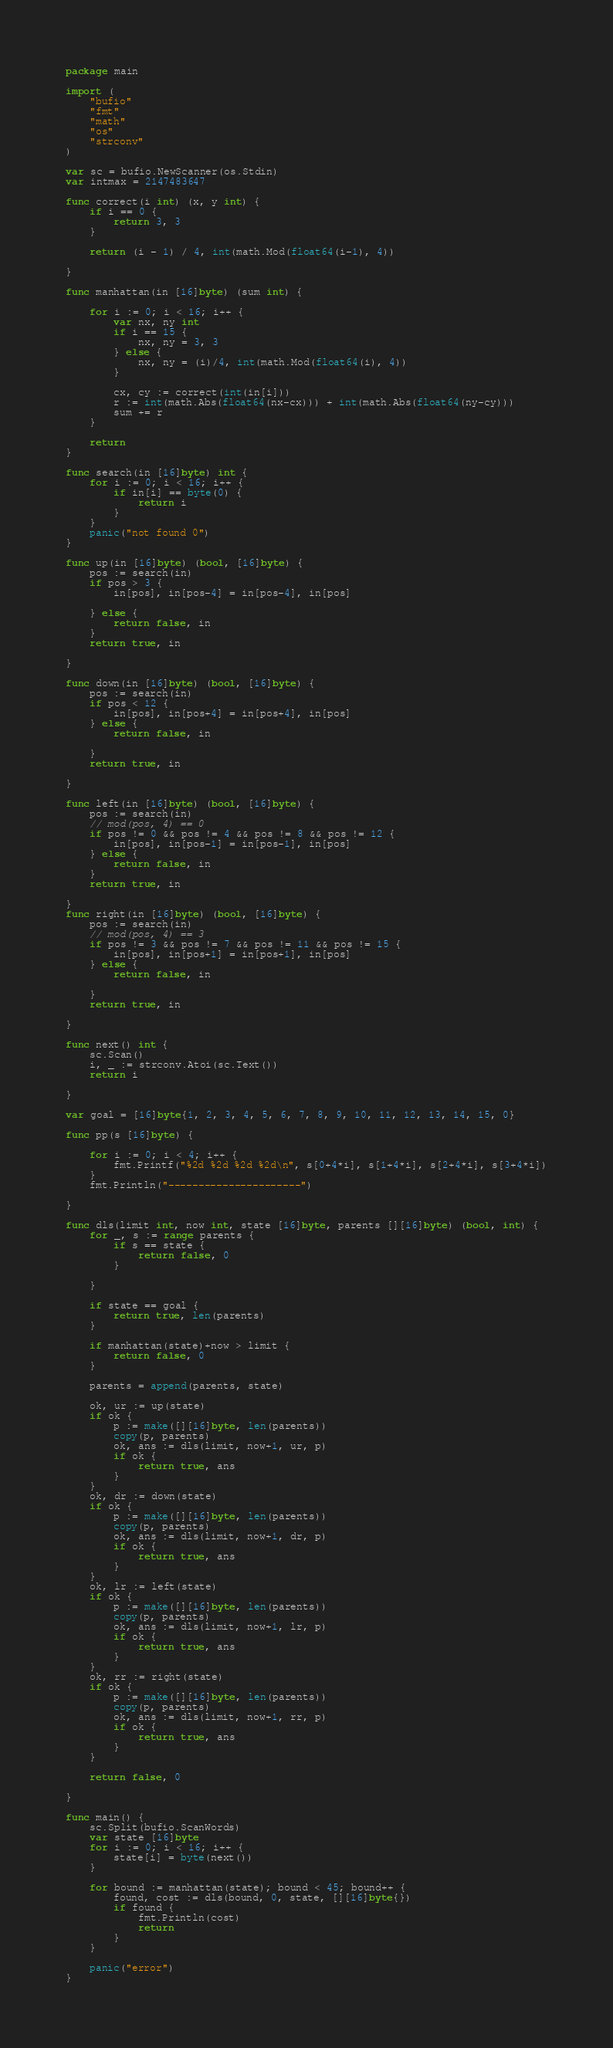<code> <loc_0><loc_0><loc_500><loc_500><_Go_>package main

import (
	"bufio"
	"fmt"
	"math"
	"os"
	"strconv"
)

var sc = bufio.NewScanner(os.Stdin)
var intmax = 2147483647

func correct(i int) (x, y int) {
	if i == 0 {
		return 3, 3
	}

	return (i - 1) / 4, int(math.Mod(float64(i-1), 4))

}

func manhattan(in [16]byte) (sum int) {

	for i := 0; i < 16; i++ {
		var nx, ny int
		if i == 15 {
			nx, ny = 3, 3
		} else {
			nx, ny = (i)/4, int(math.Mod(float64(i), 4))
		}

		cx, cy := correct(int(in[i]))
		r := int(math.Abs(float64(nx-cx))) + int(math.Abs(float64(ny-cy)))
		sum += r
	}

	return
}

func search(in [16]byte) int {
	for i := 0; i < 16; i++ {
		if in[i] == byte(0) {
			return i
		}
	}
	panic("not found 0")
}

func up(in [16]byte) (bool, [16]byte) {
	pos := search(in)
	if pos > 3 {
		in[pos], in[pos-4] = in[pos-4], in[pos]

	} else {
		return false, in
	}
	return true, in

}

func down(in [16]byte) (bool, [16]byte) {
	pos := search(in)
	if pos < 12 {
		in[pos], in[pos+4] = in[pos+4], in[pos]
	} else {
		return false, in

	}
	return true, in

}

func left(in [16]byte) (bool, [16]byte) {
	pos := search(in)
	// mod(pos, 4) == 0
	if pos != 0 && pos != 4 && pos != 8 && pos != 12 {
		in[pos], in[pos-1] = in[pos-1], in[pos]
	} else {
		return false, in
	}
	return true, in

}
func right(in [16]byte) (bool, [16]byte) {
	pos := search(in)
	// mod(pos, 4) == 3
	if pos != 3 && pos != 7 && pos != 11 && pos != 15 {
		in[pos], in[pos+1] = in[pos+1], in[pos]
	} else {
		return false, in

	}
	return true, in

}

func next() int {
	sc.Scan()
	i, _ := strconv.Atoi(sc.Text())
	return i

}

var goal = [16]byte{1, 2, 3, 4, 5, 6, 7, 8, 9, 10, 11, 12, 13, 14, 15, 0}

func pp(s [16]byte) {

	for i := 0; i < 4; i++ {
		fmt.Printf("%2d %2d %2d %2d\n", s[0+4*i], s[1+4*i], s[2+4*i], s[3+4*i])
	}
	fmt.Println("----------------------")

}

func dls(limit int, now int, state [16]byte, parents [][16]byte) (bool, int) {
	for _, s := range parents {
		if s == state {
			return false, 0
		}

	}

	if state == goal {
		return true, len(parents)
	}

	if manhattan(state)+now > limit {
		return false, 0
	}

	parents = append(parents, state)

	ok, ur := up(state)
	if ok {
		p := make([][16]byte, len(parents))
		copy(p, parents)
		ok, ans := dls(limit, now+1, ur, p)
		if ok {
			return true, ans
		}
	}
	ok, dr := down(state)
	if ok {
		p := make([][16]byte, len(parents))
		copy(p, parents)
		ok, ans := dls(limit, now+1, dr, p)
		if ok {
			return true, ans
		}
	}
	ok, lr := left(state)
	if ok {
		p := make([][16]byte, len(parents))
		copy(p, parents)
		ok, ans := dls(limit, now+1, lr, p)
		if ok {
			return true, ans
		}
	}
	ok, rr := right(state)
	if ok {
		p := make([][16]byte, len(parents))
		copy(p, parents)
		ok, ans := dls(limit, now+1, rr, p)
		if ok {
			return true, ans
		}
	}

	return false, 0

}

func main() {
	sc.Split(bufio.ScanWords)
	var state [16]byte
	for i := 0; i < 16; i++ {
		state[i] = byte(next())
	}

	for bound := manhattan(state); bound < 45; bound++ {
		found, cost := dls(bound, 0, state, [][16]byte{})
		if found {
			fmt.Println(cost)
			return
		}
	}

	panic("error")
}

</code> 